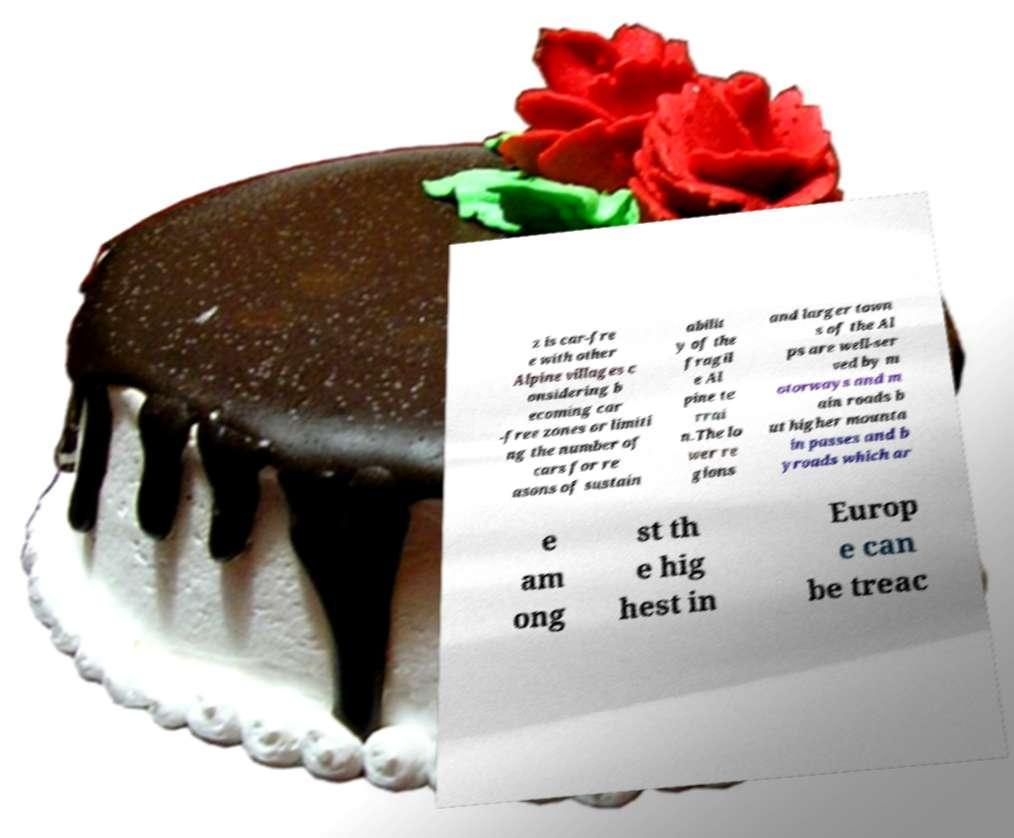For documentation purposes, I need the text within this image transcribed. Could you provide that? z is car-fre e with other Alpine villages c onsidering b ecoming car -free zones or limiti ng the number of cars for re asons of sustain abilit y of the fragil e Al pine te rrai n.The lo wer re gions and larger town s of the Al ps are well-ser ved by m otorways and m ain roads b ut higher mounta in passes and b yroads which ar e am ong st th e hig hest in Europ e can be treac 